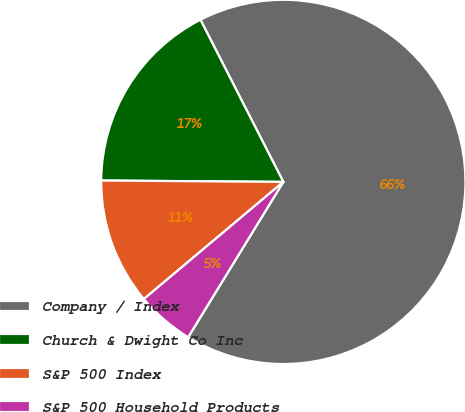Convert chart to OTSL. <chart><loc_0><loc_0><loc_500><loc_500><pie_chart><fcel>Company / Index<fcel>Church & Dwight Co Inc<fcel>S&P 500 Index<fcel>S&P 500 Household Products<nl><fcel>66.27%<fcel>17.36%<fcel>11.24%<fcel>5.13%<nl></chart> 